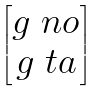<formula> <loc_0><loc_0><loc_500><loc_500>\begin{bmatrix} g _ { \ } n o \\ g _ { \ } t a \end{bmatrix}</formula> 